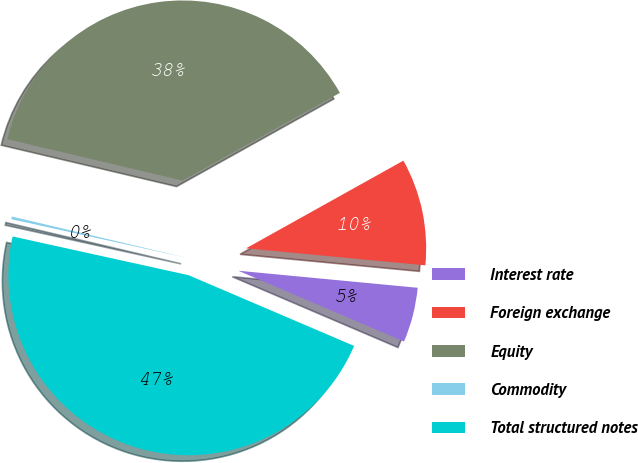Convert chart. <chart><loc_0><loc_0><loc_500><loc_500><pie_chart><fcel>Interest rate<fcel>Foreign exchange<fcel>Equity<fcel>Commodity<fcel>Total structured notes<nl><fcel>4.92%<fcel>9.6%<fcel>38.22%<fcel>0.24%<fcel>47.02%<nl></chart> 